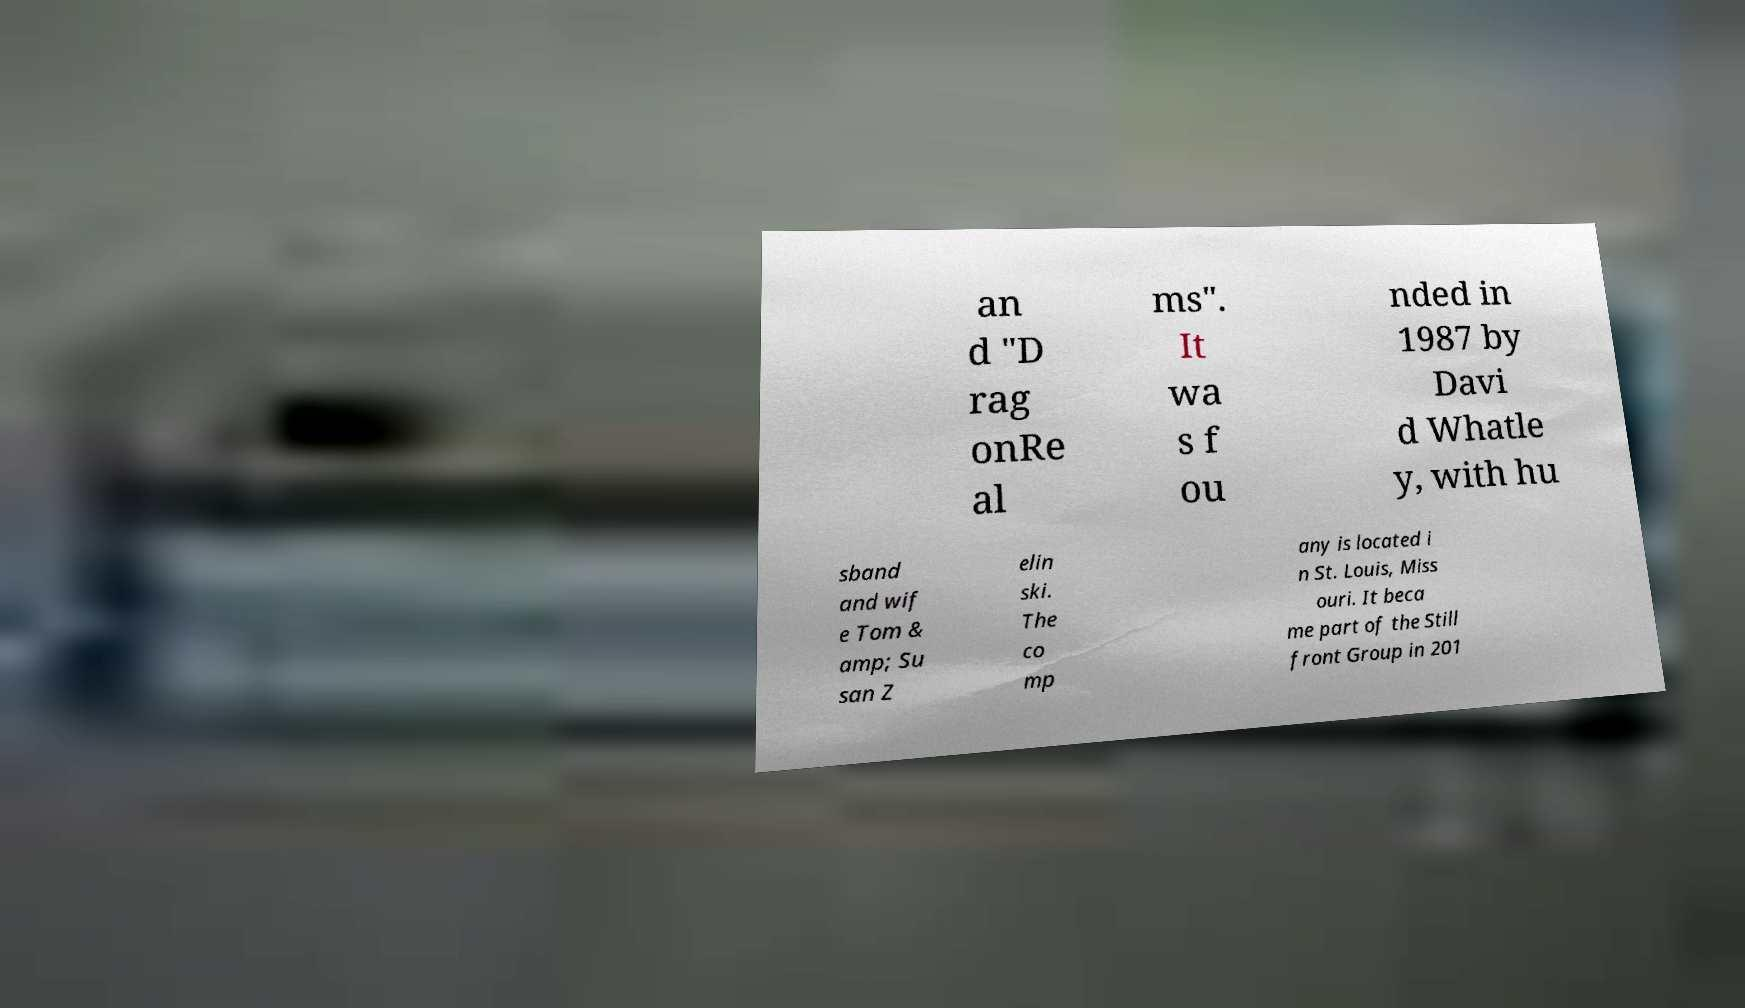What messages or text are displayed in this image? I need them in a readable, typed format. an d "D rag onRe al ms". It wa s f ou nded in 1987 by Davi d Whatle y, with hu sband and wif e Tom & amp; Su san Z elin ski. The co mp any is located i n St. Louis, Miss ouri. It beca me part of the Still front Group in 201 